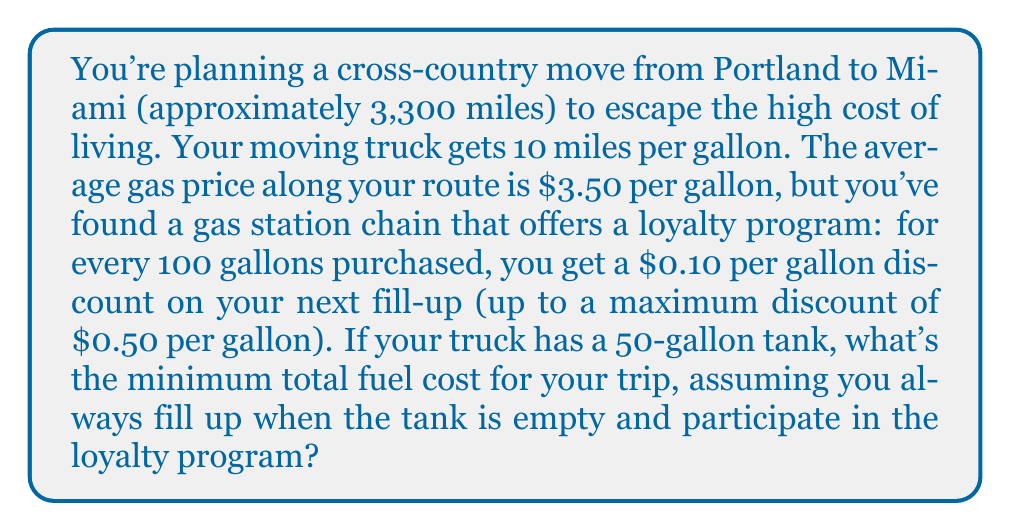What is the answer to this math problem? Let's approach this problem step-by-step:

1) First, calculate the total number of gallons needed for the trip:
   $$\text{Total gallons} = \frac{\text{Total distance}}{\text{Miles per gallon}} = \frac{3,300}{10} = 330 \text{ gallons}$$

2) Now, let's consider the loyalty program. For every 100 gallons, we get a $0.10 discount on the next fill-up. With 330 gallons, we'll get 3 full discount tiers:
   $$\text{Number of full discount tiers} = \lfloor \frac{330}{100} \rfloor = 3$$

3) This means our discount progression will be:
   - First 100 gallons: No discount
   - Next 100 gallons: $0.10 off per gallon
   - Next 100 gallons: $0.20 off per gallon
   - Remaining 30 gallons: $0.30 off per gallon

4) Let's calculate the cost for each tier:
   - First 100 gallons: $100 \times $3.50 = $350
   - Next 100 gallons: $100 \times ($3.50 - $0.10) = $340
   - Next 100 gallons: $100 \times ($3.50 - $0.20) = $330
   - Remaining 30 gallons: $30 \times ($3.50 - $0.30) = $96

5) Sum up the total cost:
   $$\text{Total cost} = $350 + $340 + $330 + $96 = $1,116$$

This is the minimum total fuel cost for the trip, taking advantage of the loyalty program and filling up when the tank is empty.
Answer: $1,116 